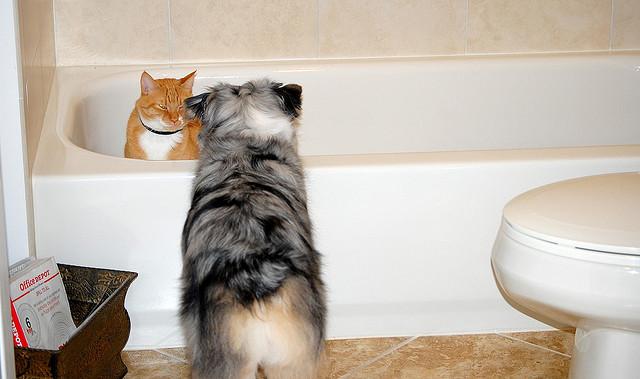Is the cat in the bathtub?
Keep it brief. Yes. Are the dog and cat fighting?
Short answer required. No. Is the dog giving the cat a bath?
Short answer required. No. 